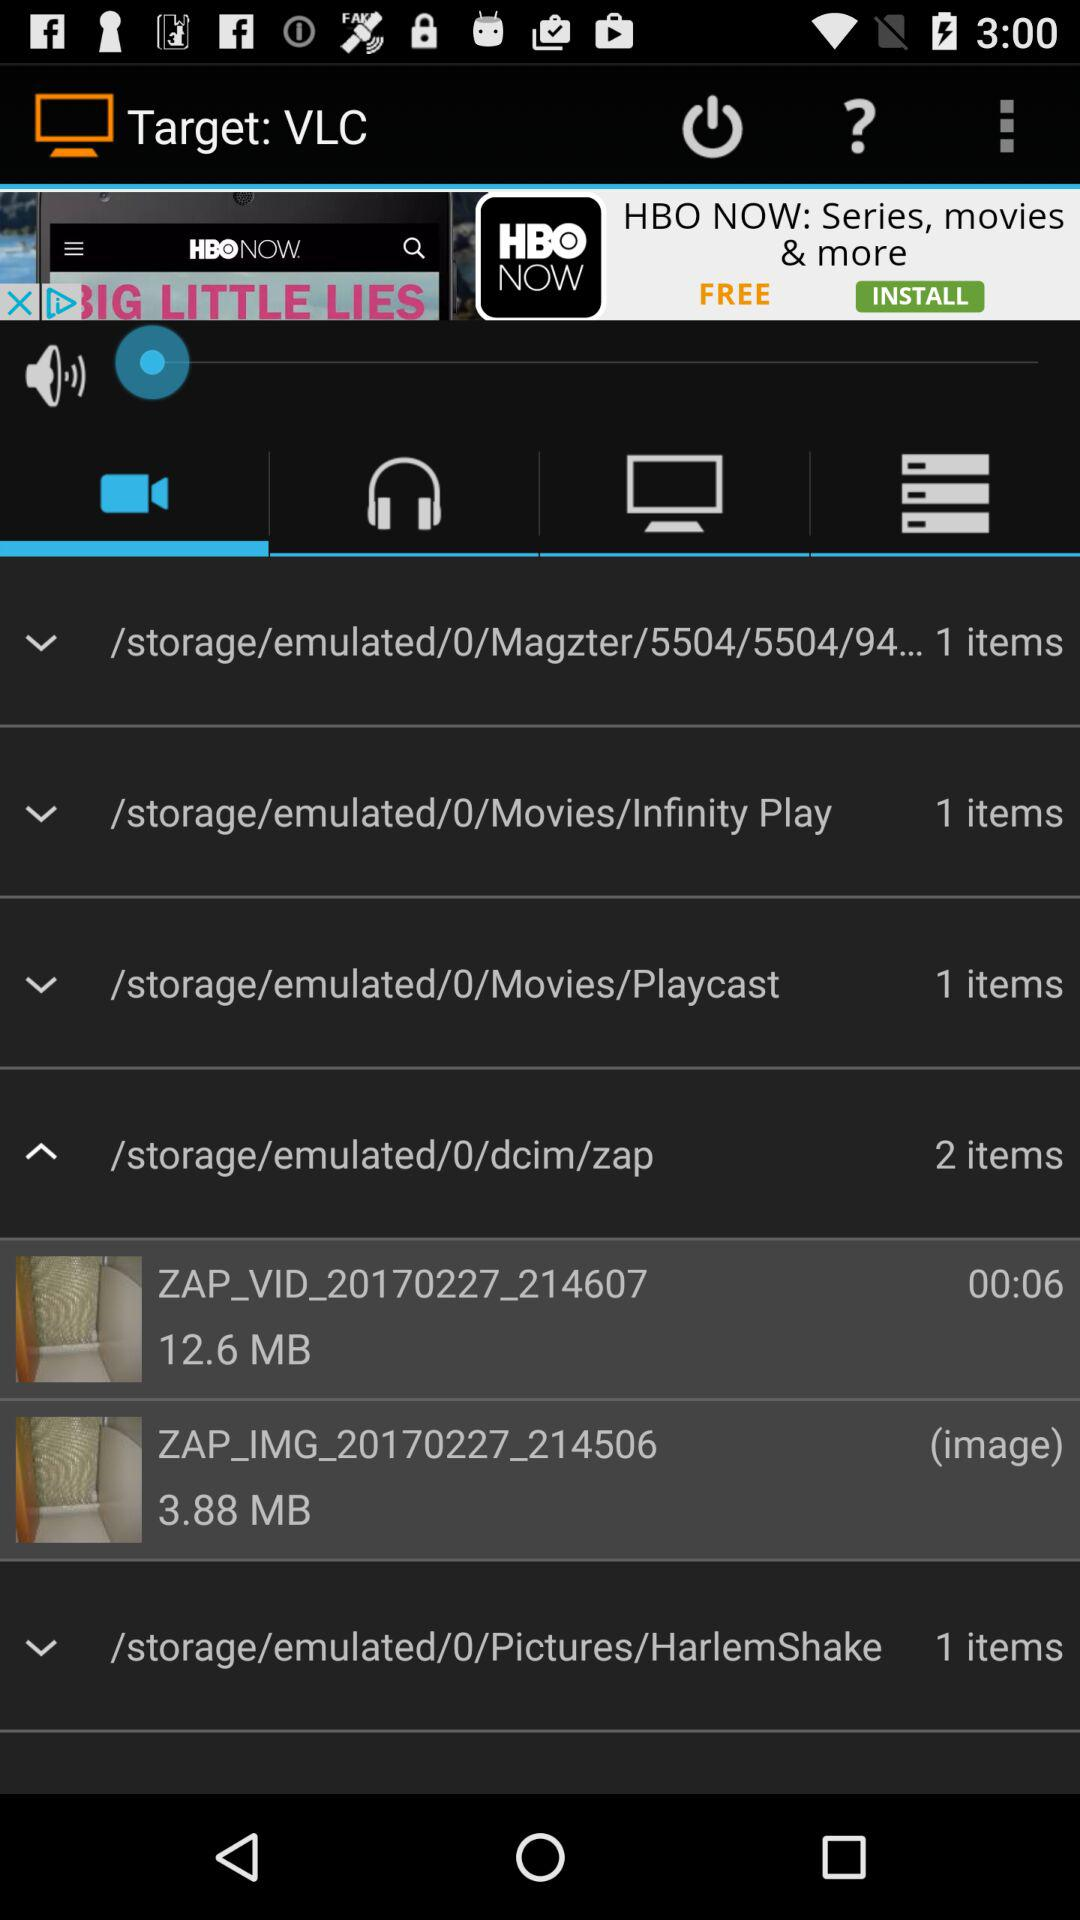What is the size of the video in the "zap" folder? The size of the video in the "zap" folder is 12.6 MB. 